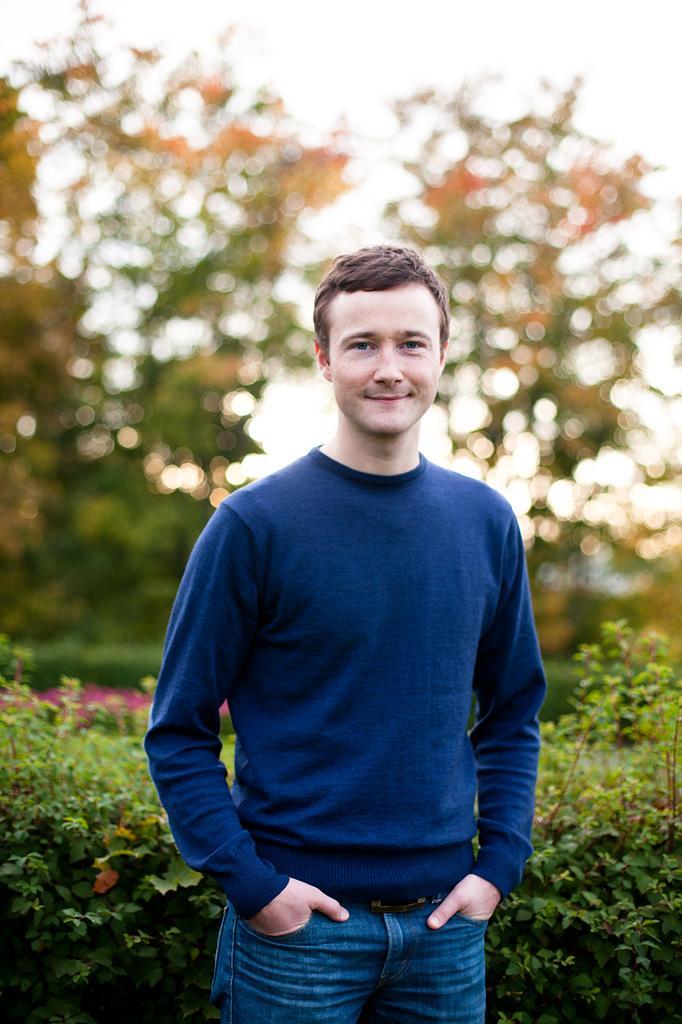Describe this image in one or two sentences. In the center of the image we can see a man standing. He is wearing a blue shirt. In the background there are bushes and trees. 